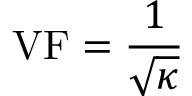<formula> <loc_0><loc_0><loc_500><loc_500>V F = { \frac { 1 } { \sqrt { \kappa } } }</formula> 